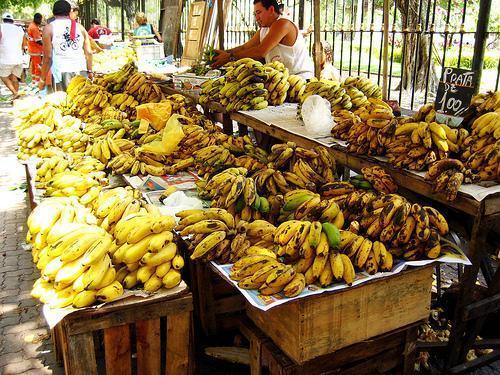How many people are sitting behind the banana stand?
Give a very brief answer. 1. 